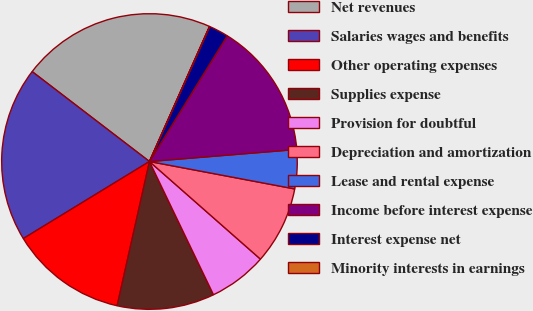Convert chart. <chart><loc_0><loc_0><loc_500><loc_500><pie_chart><fcel>Net revenues<fcel>Salaries wages and benefits<fcel>Other operating expenses<fcel>Supplies expense<fcel>Provision for doubtful<fcel>Depreciation and amortization<fcel>Lease and rental expense<fcel>Income before interest expense<fcel>Interest expense net<fcel>Minority interests in earnings<nl><fcel>21.25%<fcel>19.13%<fcel>12.76%<fcel>10.64%<fcel>6.39%<fcel>8.51%<fcel>4.27%<fcel>14.88%<fcel>2.14%<fcel>0.02%<nl></chart> 